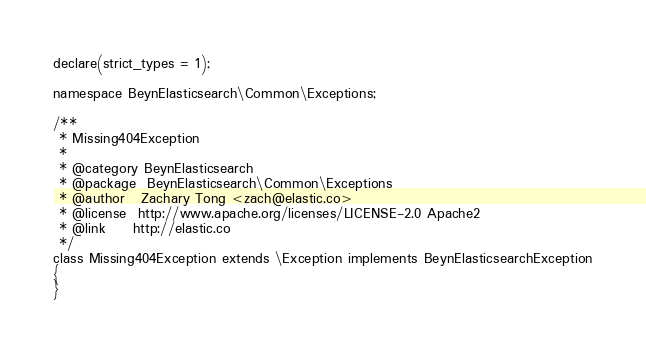Convert code to text. <code><loc_0><loc_0><loc_500><loc_500><_PHP_>
declare(strict_types = 1);

namespace BeynElasticsearch\Common\Exceptions;

/**
 * Missing404Exception
 *
 * @category BeynElasticsearch
 * @package  BeynElasticsearch\Common\Exceptions
 * @author   Zachary Tong <zach@elastic.co>
 * @license  http://www.apache.org/licenses/LICENSE-2.0 Apache2
 * @link     http://elastic.co
 */
class Missing404Exception extends \Exception implements BeynElasticsearchException
{
}
</code> 